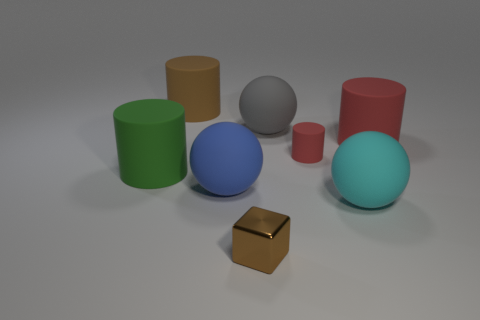Which objects in the image are casting the most pronounced shadows, and what does this suggest about the lighting source? The green cylinder and the red cylinder are casting the most pronounced shadows towards the bottom left, which suggests the primary lighting source is positioned above and to the right of the objects. 